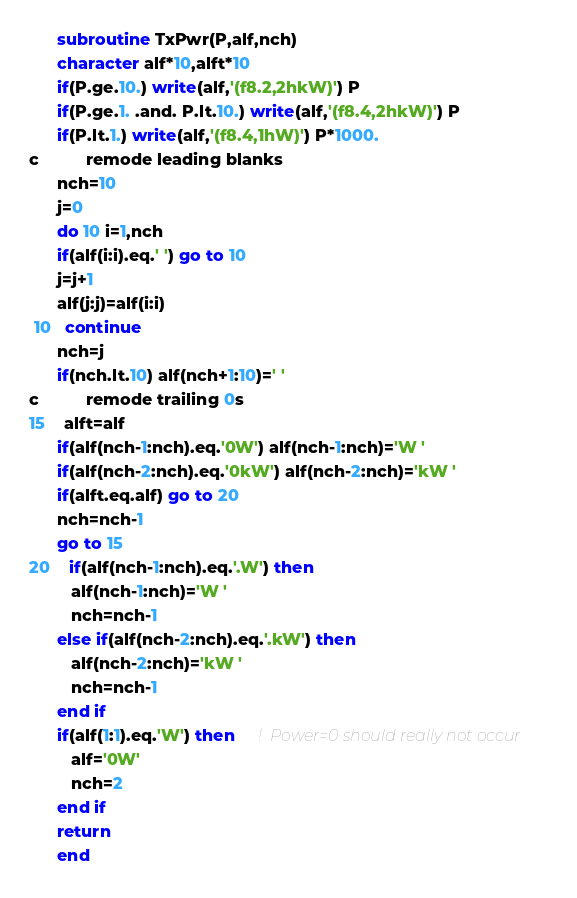Convert code to text. <code><loc_0><loc_0><loc_500><loc_500><_FORTRAN_>
      subroutine TxPwr(P,alf,nch)
      character alf*10,alft*10
      if(P.ge.10.) write(alf,'(f8.2,2hkW)') P
      if(P.ge.1. .and. P.lt.10.) write(alf,'(f8.4,2hkW)') P
      if(P.lt.1.) write(alf,'(f8.4,1hW)') P*1000.
c          remode leading blanks
      nch=10
      j=0
      do 10 i=1,nch
      if(alf(i:i).eq.' ') go to 10
      j=j+1
      alf(j:j)=alf(i:i)
 10   continue
      nch=j
      if(nch.lt.10) alf(nch+1:10)=' '
c          remode trailing 0s
15    alft=alf
      if(alf(nch-1:nch).eq.'0W') alf(nch-1:nch)='W '
      if(alf(nch-2:nch).eq.'0kW') alf(nch-2:nch)='kW '
      if(alft.eq.alf) go to 20
      nch=nch-1
      go to 15
20    if(alf(nch-1:nch).eq.'.W') then
         alf(nch-1:nch)='W '
         nch=nch-1
      else if(alf(nch-2:nch).eq.'.kW') then
         alf(nch-2:nch)='kW '
         nch=nch-1
      end if
      if(alf(1:1).eq.'W') then     !  Power=0 should really not occur
         alf='0W'
         nch=2
      end if
      return
      end
</code> 